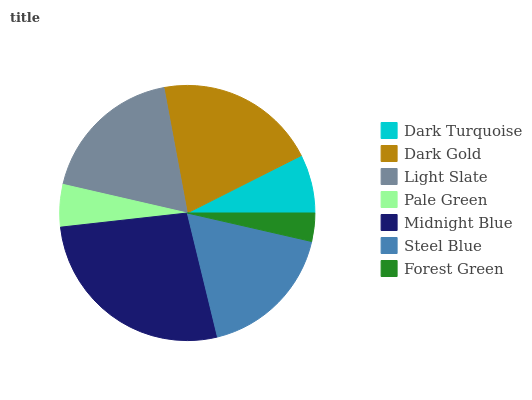Is Forest Green the minimum?
Answer yes or no. Yes. Is Midnight Blue the maximum?
Answer yes or no. Yes. Is Dark Gold the minimum?
Answer yes or no. No. Is Dark Gold the maximum?
Answer yes or no. No. Is Dark Gold greater than Dark Turquoise?
Answer yes or no. Yes. Is Dark Turquoise less than Dark Gold?
Answer yes or no. Yes. Is Dark Turquoise greater than Dark Gold?
Answer yes or no. No. Is Dark Gold less than Dark Turquoise?
Answer yes or no. No. Is Steel Blue the high median?
Answer yes or no. Yes. Is Steel Blue the low median?
Answer yes or no. Yes. Is Midnight Blue the high median?
Answer yes or no. No. Is Midnight Blue the low median?
Answer yes or no. No. 